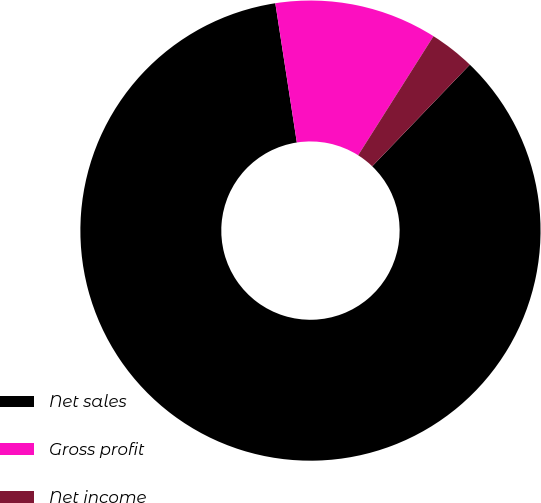Convert chart. <chart><loc_0><loc_0><loc_500><loc_500><pie_chart><fcel>Net sales<fcel>Gross profit<fcel>Net income<nl><fcel>85.38%<fcel>11.42%<fcel>3.2%<nl></chart> 